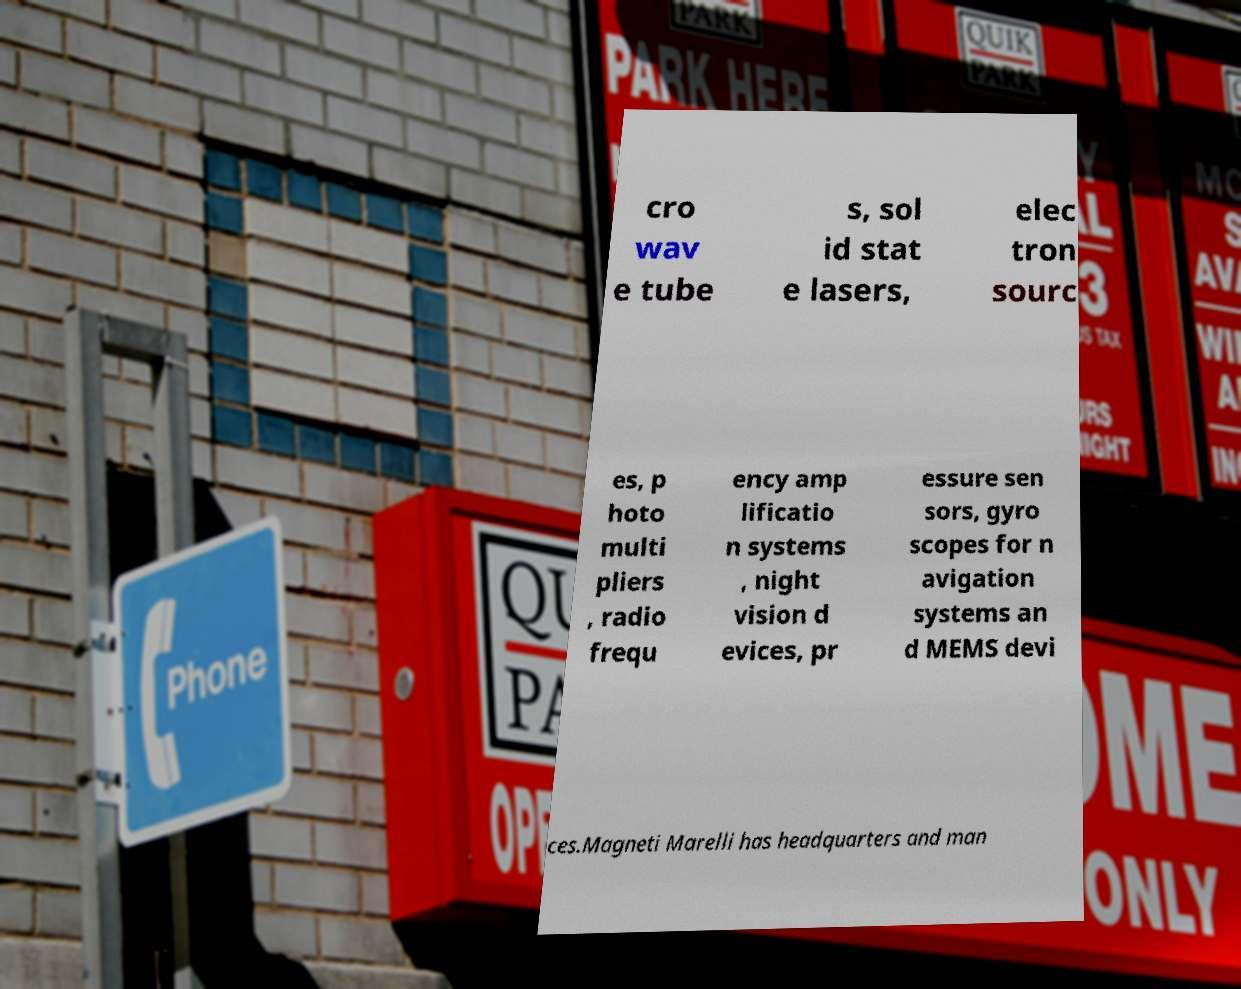Could you extract and type out the text from this image? cro wav e tube s, sol id stat e lasers, elec tron sourc es, p hoto multi pliers , radio frequ ency amp lificatio n systems , night vision d evices, pr essure sen sors, gyro scopes for n avigation systems an d MEMS devi ces.Magneti Marelli has headquarters and man 